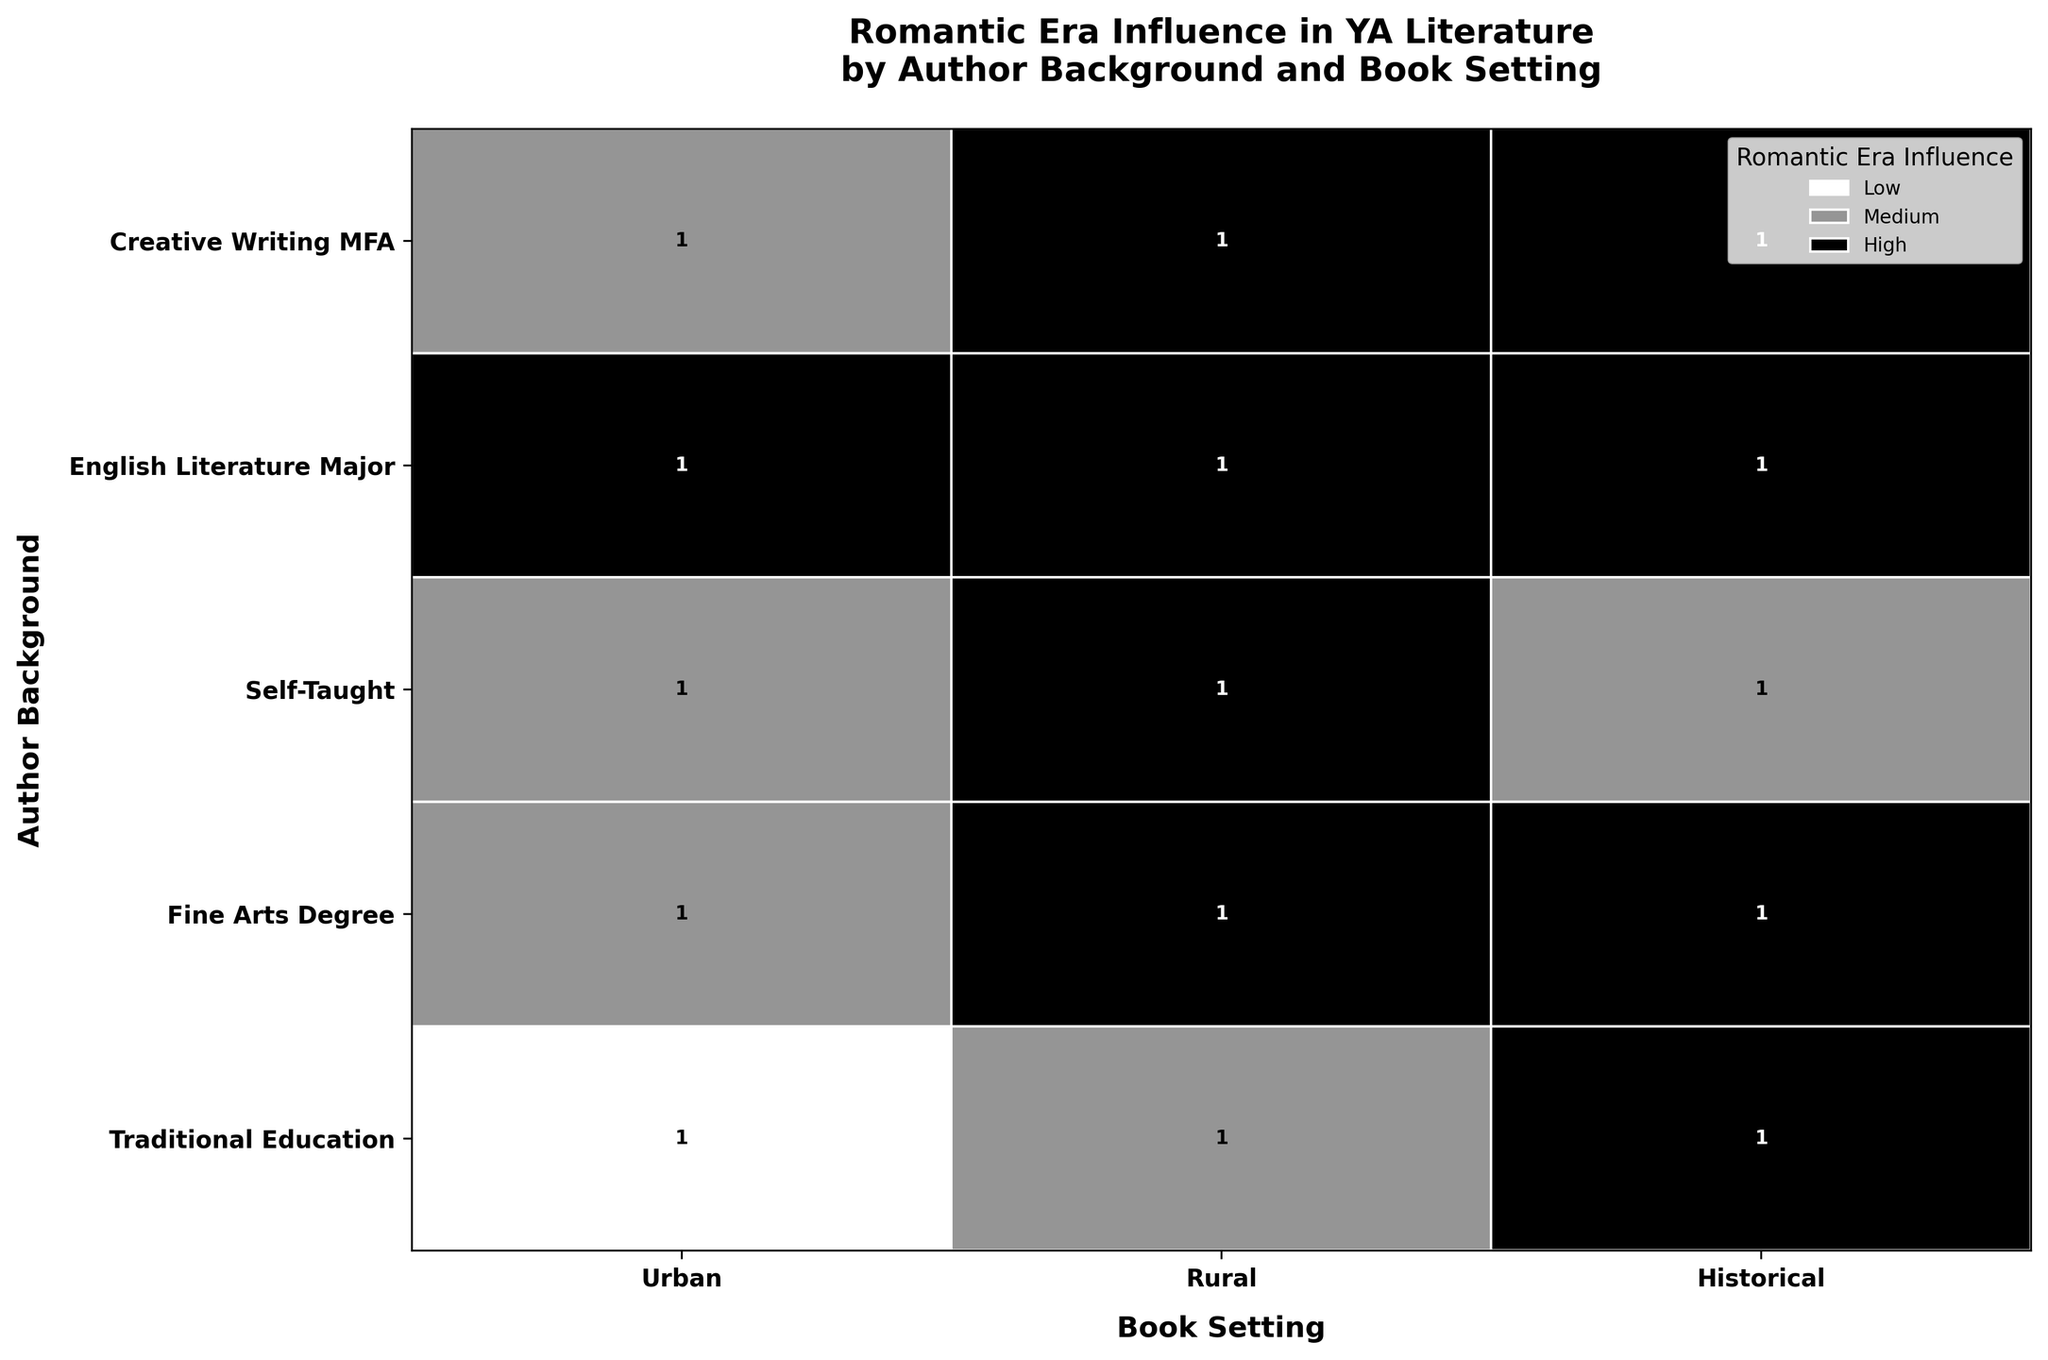What is the title of the figure? The title is typically located at the top of the figure. It provides a concise description of what the figure represents.
Answer: Romantic Era Influence in YA Literature by Author Background and Book Setting Which author background has the highest overall influence from the Romantic Era? By looking at the y-axis (author background), we see that "English Literature Major" and "Creative Writing MFA" have the highest dark-grey (indicating 'High') areas across all book settings.
Answer: English Literature Major and Creative Writing MFA In which book setting do authors with fine arts degrees show medium Romantic Era influence? Check the "Fine Arts Degree" row and see where the grey patches (indicating 'Medium') are located under the columns labeled by book setting. The grey patch for 'Medium' influence appears under the "Urban" book setting.
Answer: Urban Which book setting is most frequently associated with high Romantic Era influence for self-taught authors? Observe the "Self-Taught" row and identify where the dark-grey patches (indicating 'High') are present. The patch with the darkest-grey color is under the "Rural" setting.
Answer: Rural How many book settings do traditionally educated authors have with medium Romantic Era influence? In the "Traditional Education" row, look for grey patches indicating 'Medium' Romantic Era influence, and count how many distinct book settings these patches appear under. The grey patches are seen under "Urban" and "Rural."
Answer: Two For which author background is the influence level 'High' equally distributed across all book settings? Identify the author backgrounds with dark-grey patches in equal height across all book settings. The background that fits this condition is "English Literature Major."
Answer: English Literature Major Do any author backgrounds have a low influence level in rural settings? Look at the "Rural" column and verify if there's a light-grey patch (indicating 'Low') present in any of the rows for different author backgrounds. There are no such patches.
Answer: No How many distinct romantic era influences are present for each book setting? In each column (book setting), count the different shades of grey (representing 'Low', 'Medium', and 'High'). Each column shows three distinct levels of influence in total.
Answer: Three Compare the Romantic Era influence for ‘Urban’ settings between Creative Writing MFA and Traditional Education backgrounds. Which has a higher influence level? Compare the height of the corresponding grey patches in the "Urban" column for "Creative Writing MFA" and "Traditional Education." The former has a higher proportion of medium influence but overall the influence level appears similar.
Answer: Similar What is the proportion of ‘High’ influence levels for books set in historical contexts by authors with traditional education? Check the height of the dark-grey patch for "Historical" book settings in the "Traditional Education" row relative to the entire height of that segment. It's fully dark-grey, indicating 'High' as the only influence level present.
Answer: 100% 